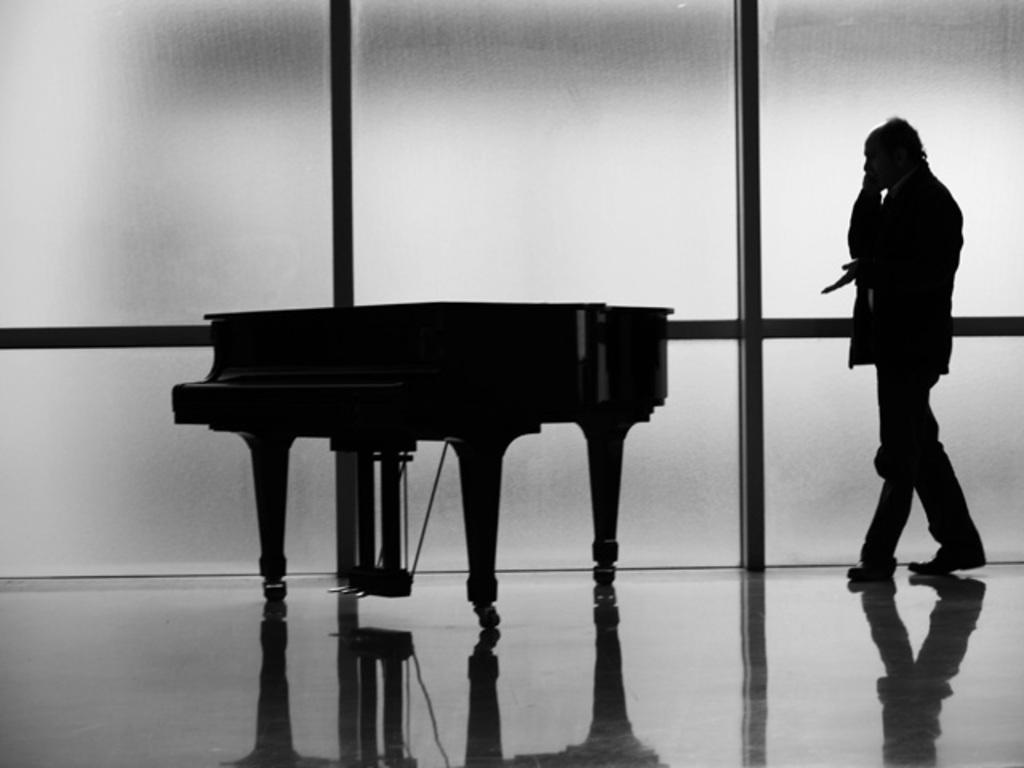Describe this image in one or two sentences. In this black and white picture there is a man walking. There is also a piano table in the room. In the background there is wall. 